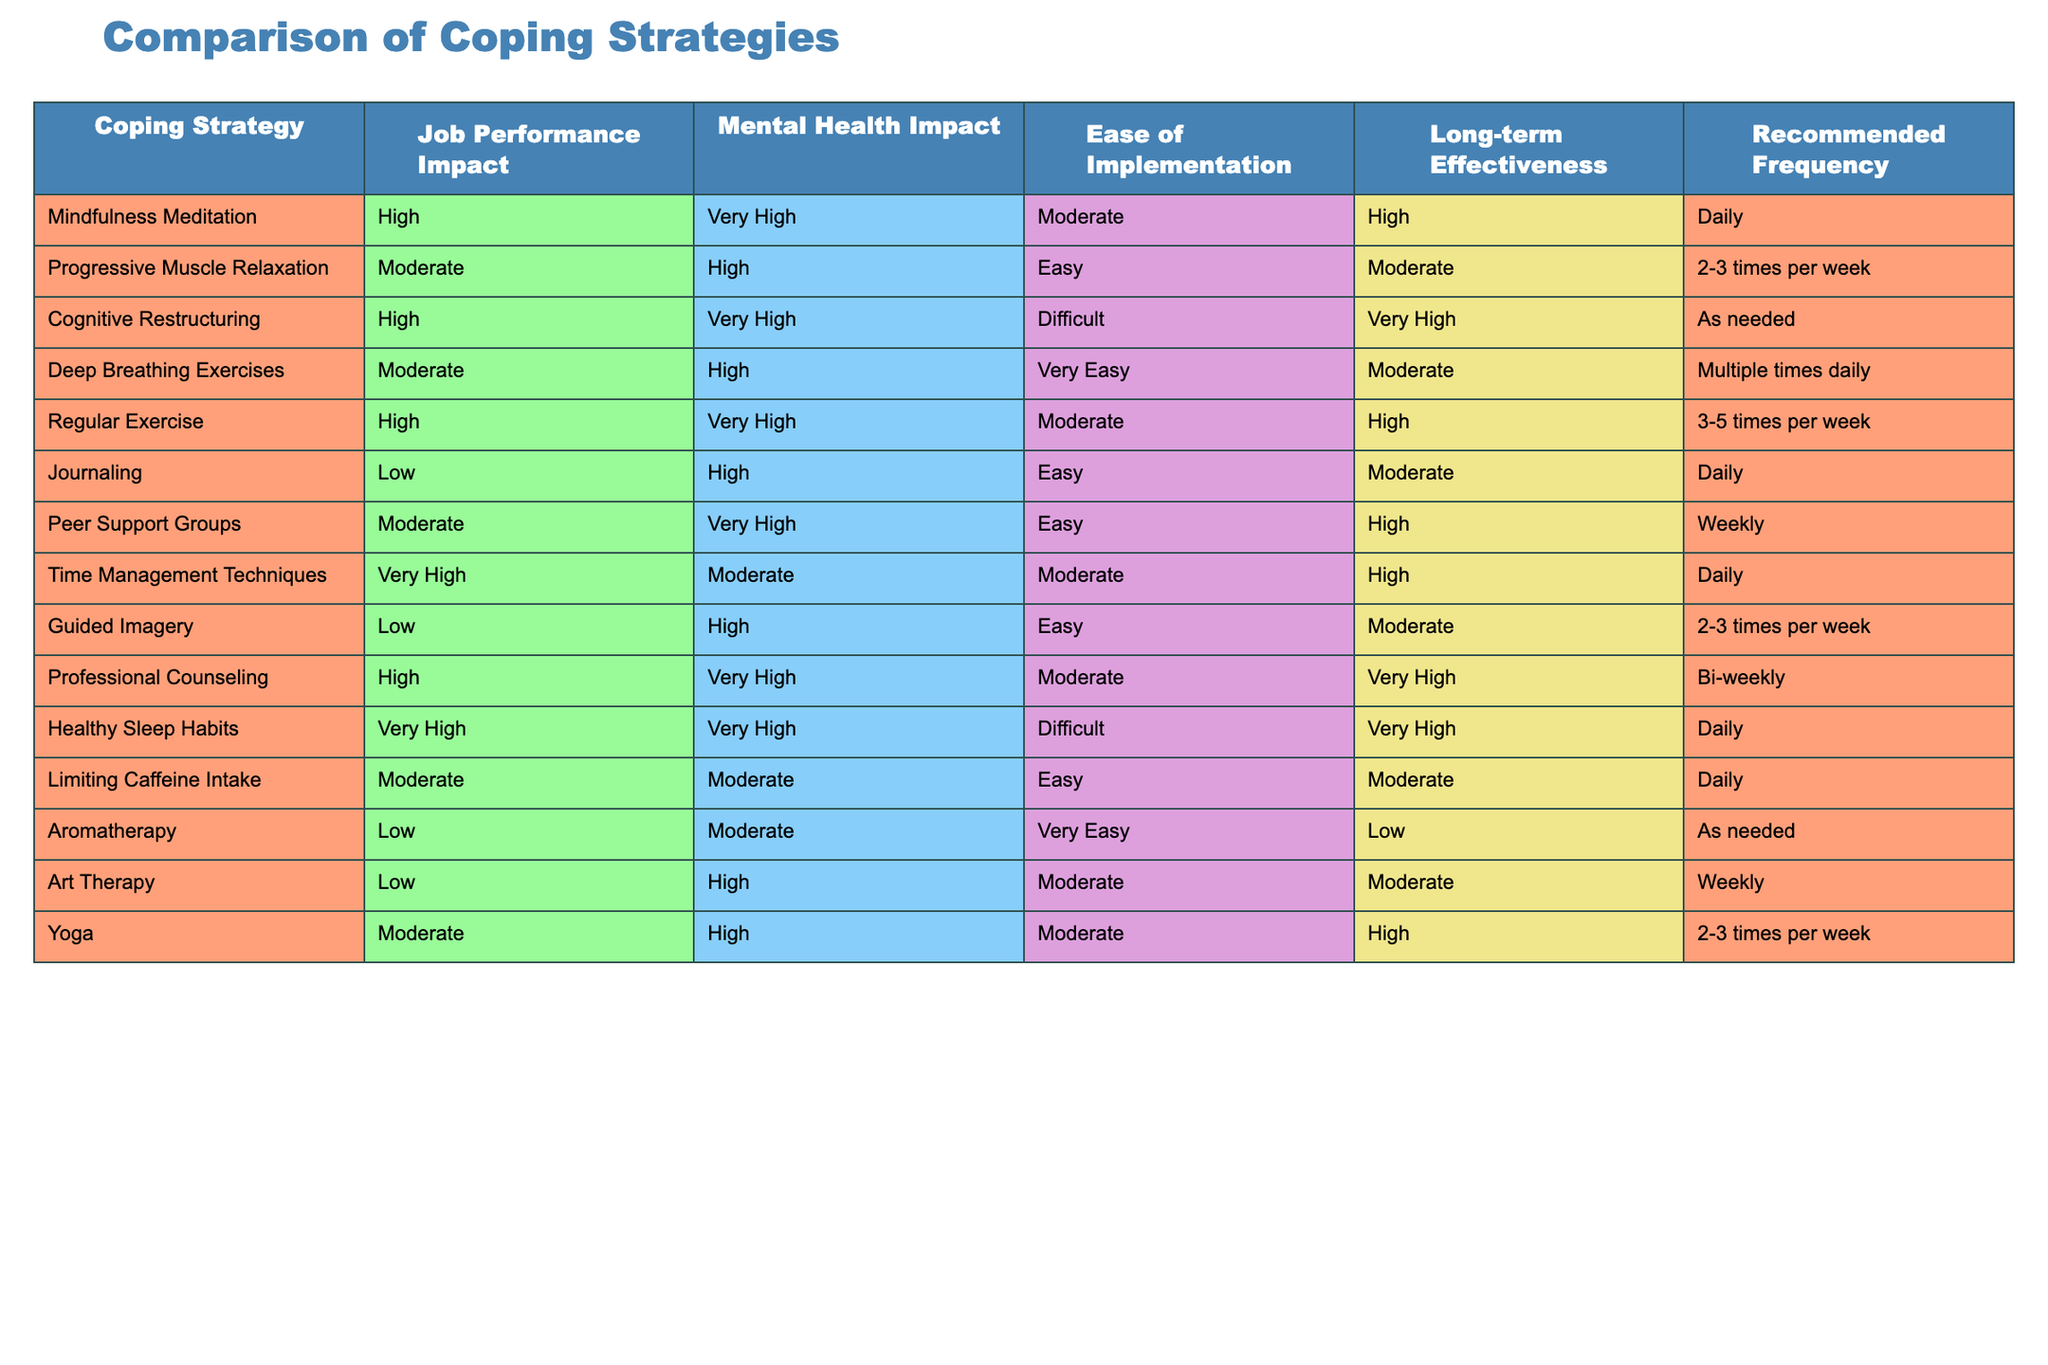What is the impact of Healthy Sleep Habits on Job Performance? The table shows that the impact of Healthy Sleep Habits on Job Performance is categorized as Very High.
Answer: Very High Which coping strategy requires the most frequent implementation according to the table? By reviewing the recommended frequency column, Mindfulness Meditation and Healthy Sleep Habits both require daily implementation, which is the most frequent among the listed strategies.
Answer: Mindfulness Meditation and Healthy Sleep Habits Is Progressive Muscle Relaxation easy to implement? The corresponding column indicates that the ease of implementation for Progressive Muscle Relaxation is rated as Easy.
Answer: Yes Which coping strategies have a Low impact on Job Performance? The table reveals three strategies with a Low impact on Job Performance: Journaling, Guided Imagery, and Aromatherapy.
Answer: Journaling, Guided Imagery, and Aromatherapy What is the average Mental Health Impact rating for all strategies listed in the table? First, the Mental Health Impact ratings need to be numerically assigned: Very High (4), High (3), Moderate (2), and Low (1). Then, summing the ratings (e.g., Progressive Muscle Relaxation = 3, etc.) across the eight listed strategies divided by the total number (14): (3+3+4+2+4+3+2+1+3+2+4+3+2+1= 39), resulting in an average of 39/14 ≈ 2.79, which corresponds to Moderate.
Answer: Moderate Does Cognitive Restructuring have a Very High Long-term Effectiveness rating? By checking the Long-term Effectiveness column for Cognitive Restructuring, the rating is Very High.
Answer: Yes Which coping strategy has the highest Job Performance Impact and is also easy to implement? After reviewing the Job Performance Impact column, Time Management Techniques is rated as Very High, and looking at the ease of implementation column, it is rated as Moderate, thus it does not fulfill conditions on ease. However, other strategies such as Progressive Muscle Relaxation (Moderate impact) and Deep Breathing Exercises (Moderate impact) are easy to implement. No strategies meet both criteria of being Very High impact and easy to implement.
Answer: None What is the Mental Health Impact of using Peer Support Groups once a week? The table indicates that the Mental Health Impact of Peer Support Groups is categorized as Very High.
Answer: Very High How many strategies have a Moderate impact on Mental Health? By reviewing the Mental Health Impact column, three strategies are identified as having a Moderate impact: Limiting Caffeine Intake, Guided Imagery, and Time Management Techniques.
Answer: Three 